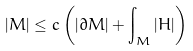Convert formula to latex. <formula><loc_0><loc_0><loc_500><loc_500>| M | \leq c \left ( | \partial M | + \int _ { M } | H | \right )</formula> 